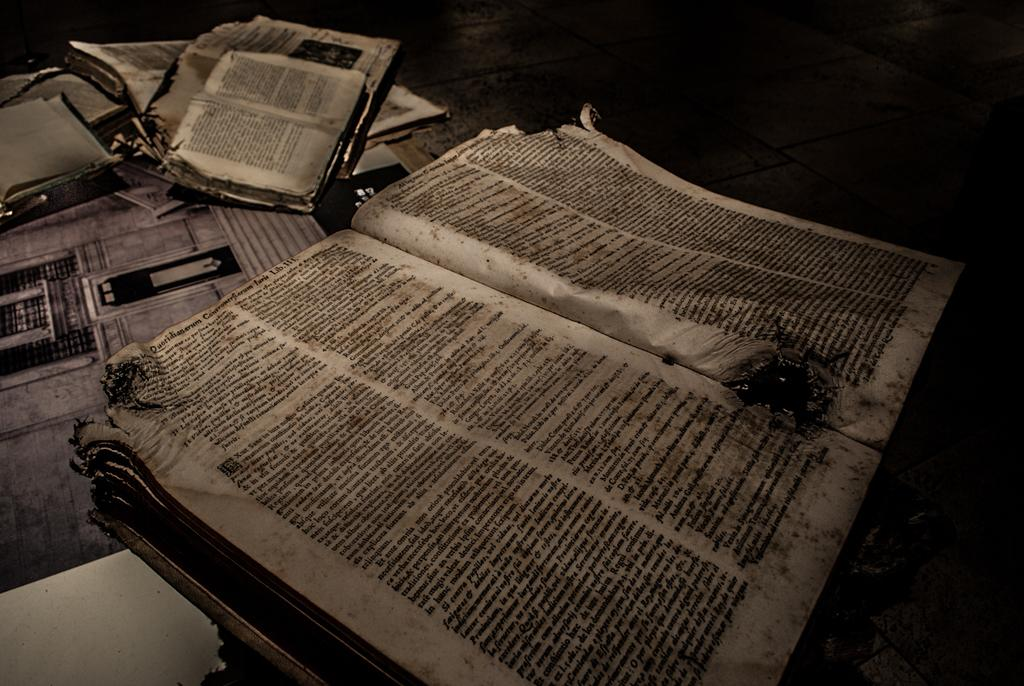<image>
Describe the image concisely. A badly damaged book lay open with the last word on the left title of LIB 111. 